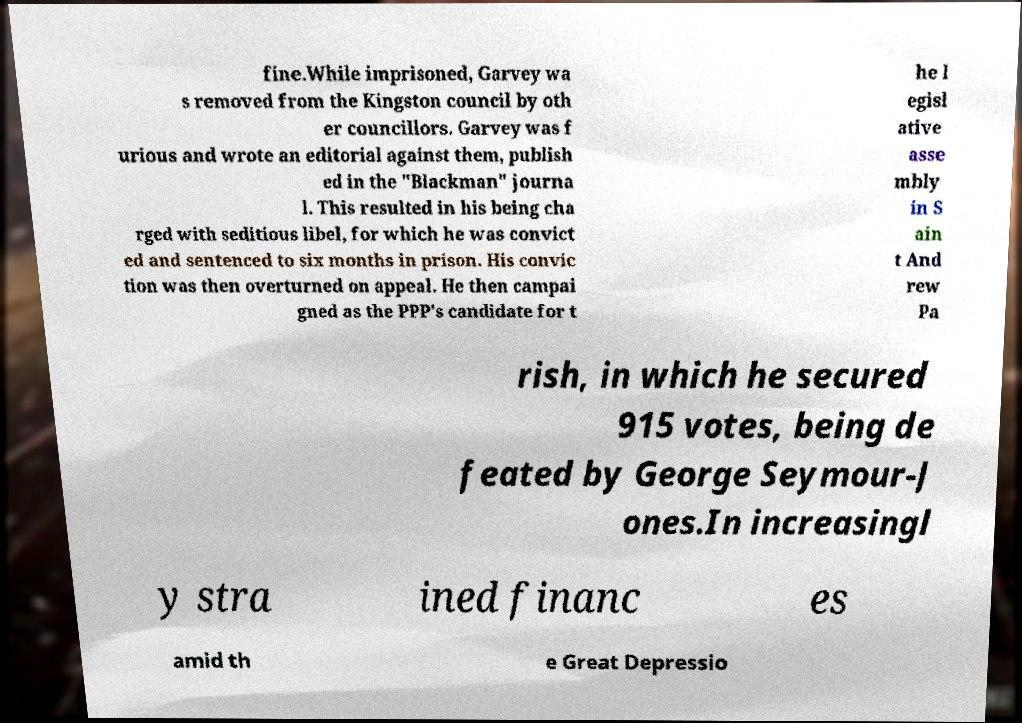Could you assist in decoding the text presented in this image and type it out clearly? fine.While imprisoned, Garvey wa s removed from the Kingston council by oth er councillors. Garvey was f urious and wrote an editorial against them, publish ed in the "Blackman" journa l. This resulted in his being cha rged with seditious libel, for which he was convict ed and sentenced to six months in prison. His convic tion was then overturned on appeal. He then campai gned as the PPP's candidate for t he l egisl ative asse mbly in S ain t And rew Pa rish, in which he secured 915 votes, being de feated by George Seymour-J ones.In increasingl y stra ined financ es amid th e Great Depressio 